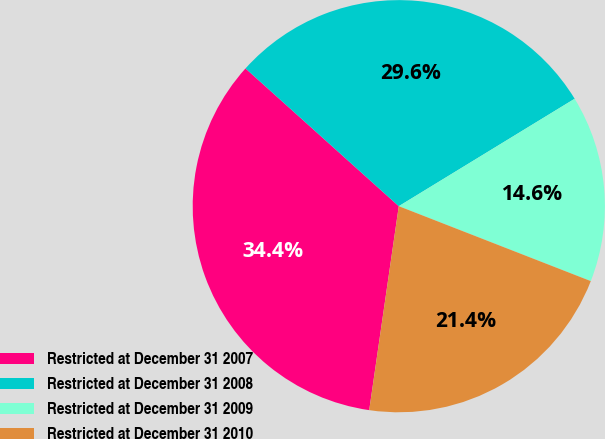Convert chart to OTSL. <chart><loc_0><loc_0><loc_500><loc_500><pie_chart><fcel>Restricted at December 31 2007<fcel>Restricted at December 31 2008<fcel>Restricted at December 31 2009<fcel>Restricted at December 31 2010<nl><fcel>34.36%<fcel>29.62%<fcel>14.65%<fcel>21.37%<nl></chart> 